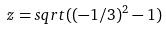<formula> <loc_0><loc_0><loc_500><loc_500>z = s q r t ( ( - 1 / 3 ) ^ { 2 } - 1 )</formula> 